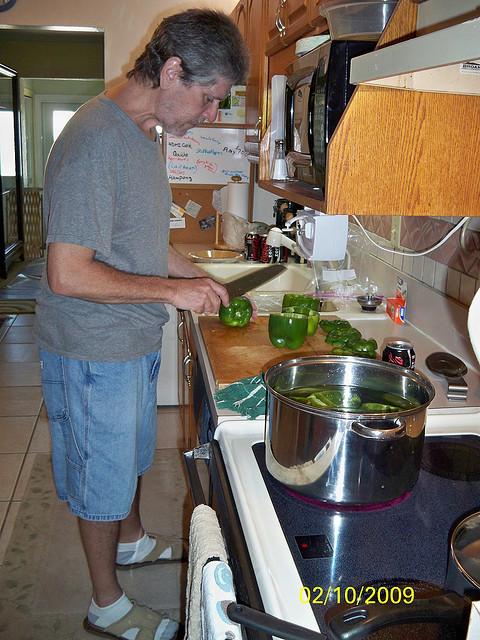What is being cut?
Write a very short answer. Peppers. When was the photo taken?
Be succinct. 02/10/2009. What color is the burner on the stove?
Short answer required. Black. How cooking method is he using?
Concise answer only. Boiling. Is the man wearing pants?
Answer briefly. No. What vegetable is the man cutting?
Quick response, please. Green pepper. 